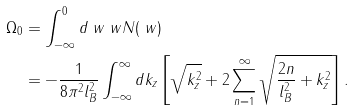<formula> <loc_0><loc_0><loc_500><loc_500>\Omega _ { 0 } & = \int _ { - \infty } ^ { 0 } d \ w \ w N ( \ w ) \\ & = - \frac { 1 } { 8 \pi ^ { 2 } l _ { B } ^ { 2 } } \int _ { - \infty } ^ { \infty } d k _ { z } \left [ \sqrt { k _ { z } ^ { 2 } } + 2 \sum _ { n = 1 } ^ { \infty } \sqrt { \frac { 2 n } { l _ { B } ^ { 2 } } + k _ { z } ^ { 2 } } \right ] .</formula> 